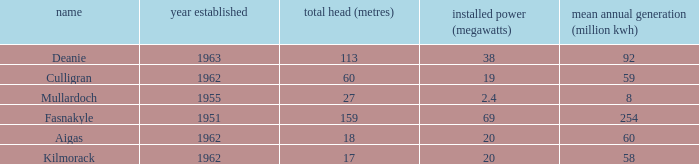What is the earliest Year commissioned wiht an Average annual output greater than 58 and Installed capacity of 20? 1962.0. 